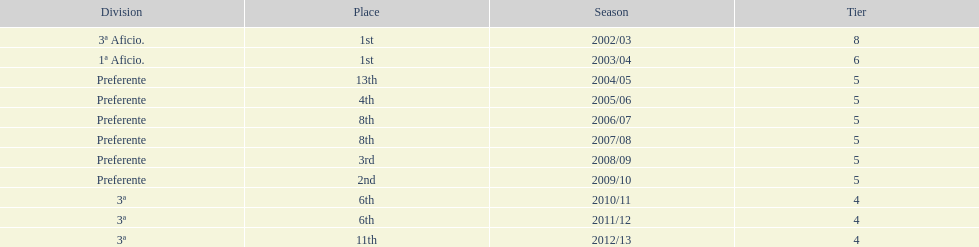Which division has the largest number of ranks? Preferente. 